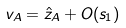Convert formula to latex. <formula><loc_0><loc_0><loc_500><loc_500>v _ { A } = \hat { z } _ { A } + O ( s _ { 1 } )</formula> 